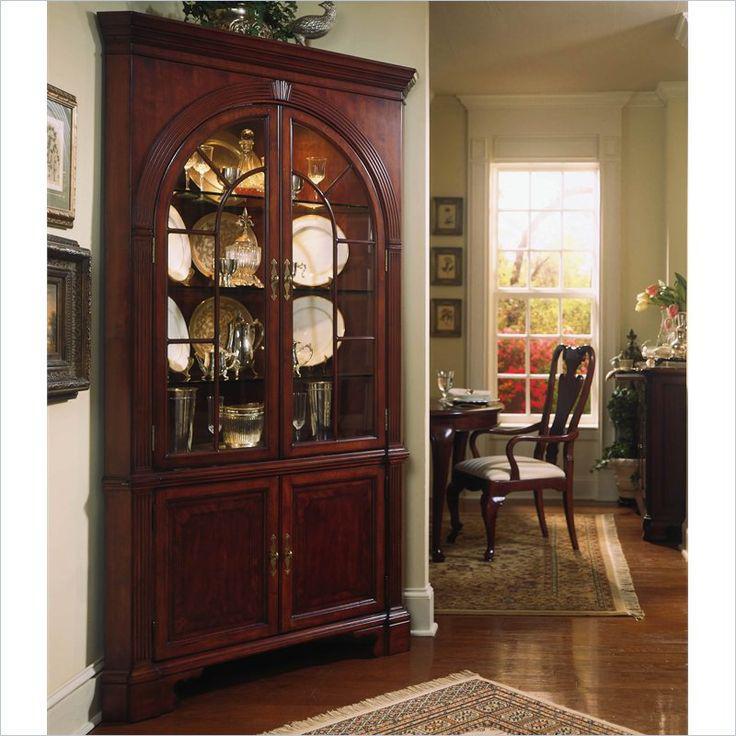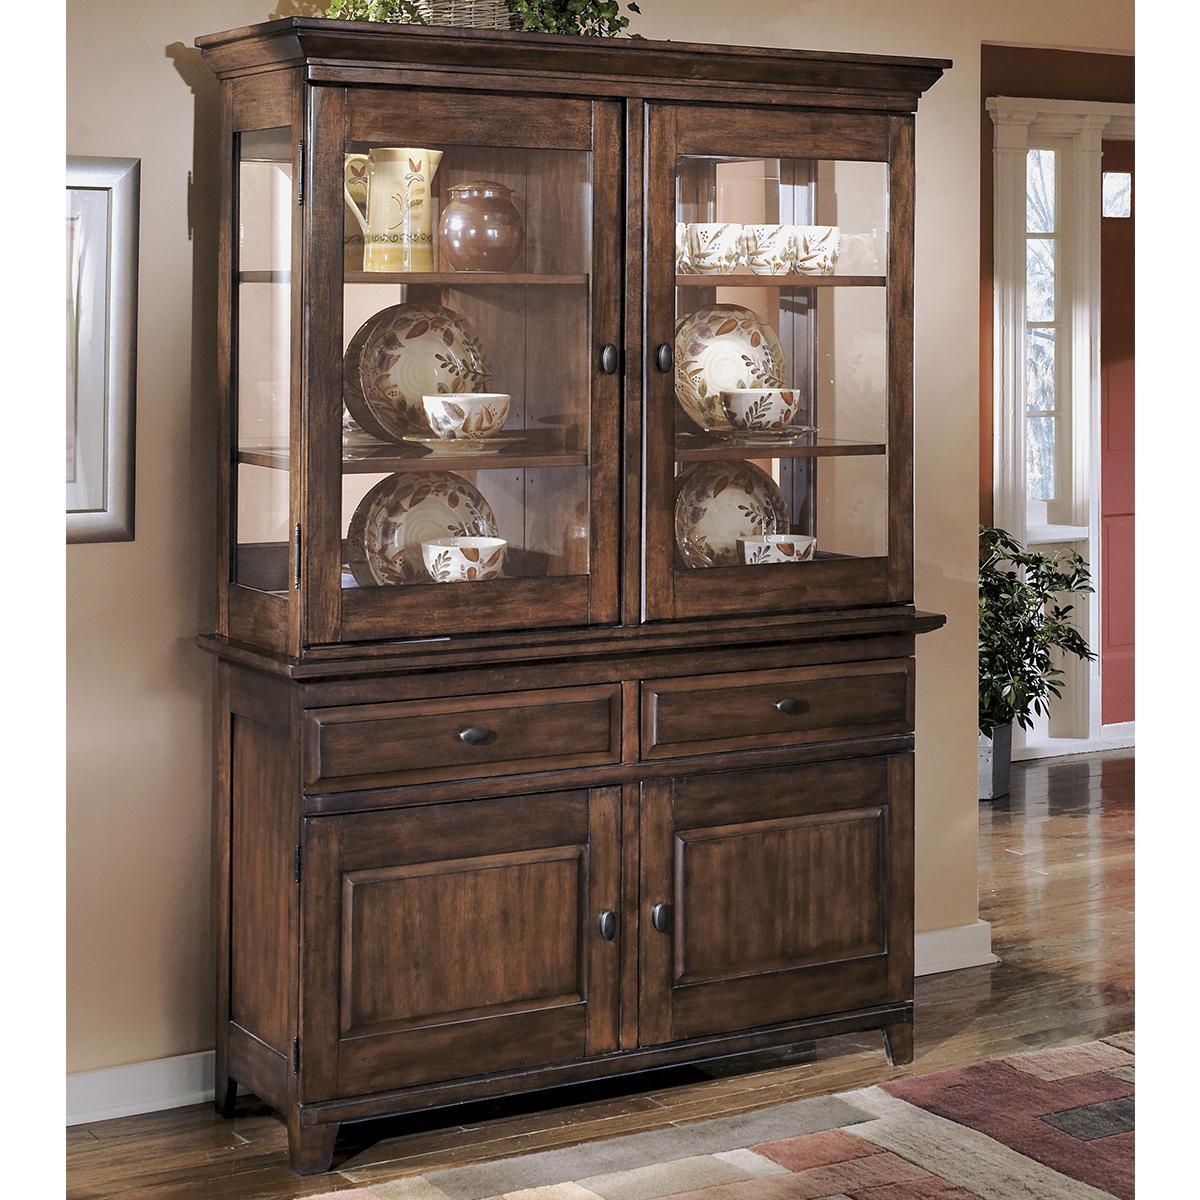The first image is the image on the left, the second image is the image on the right. Given the left and right images, does the statement "One of the cabinet fronts is not flat across the top." hold true? Answer yes or no. No. 